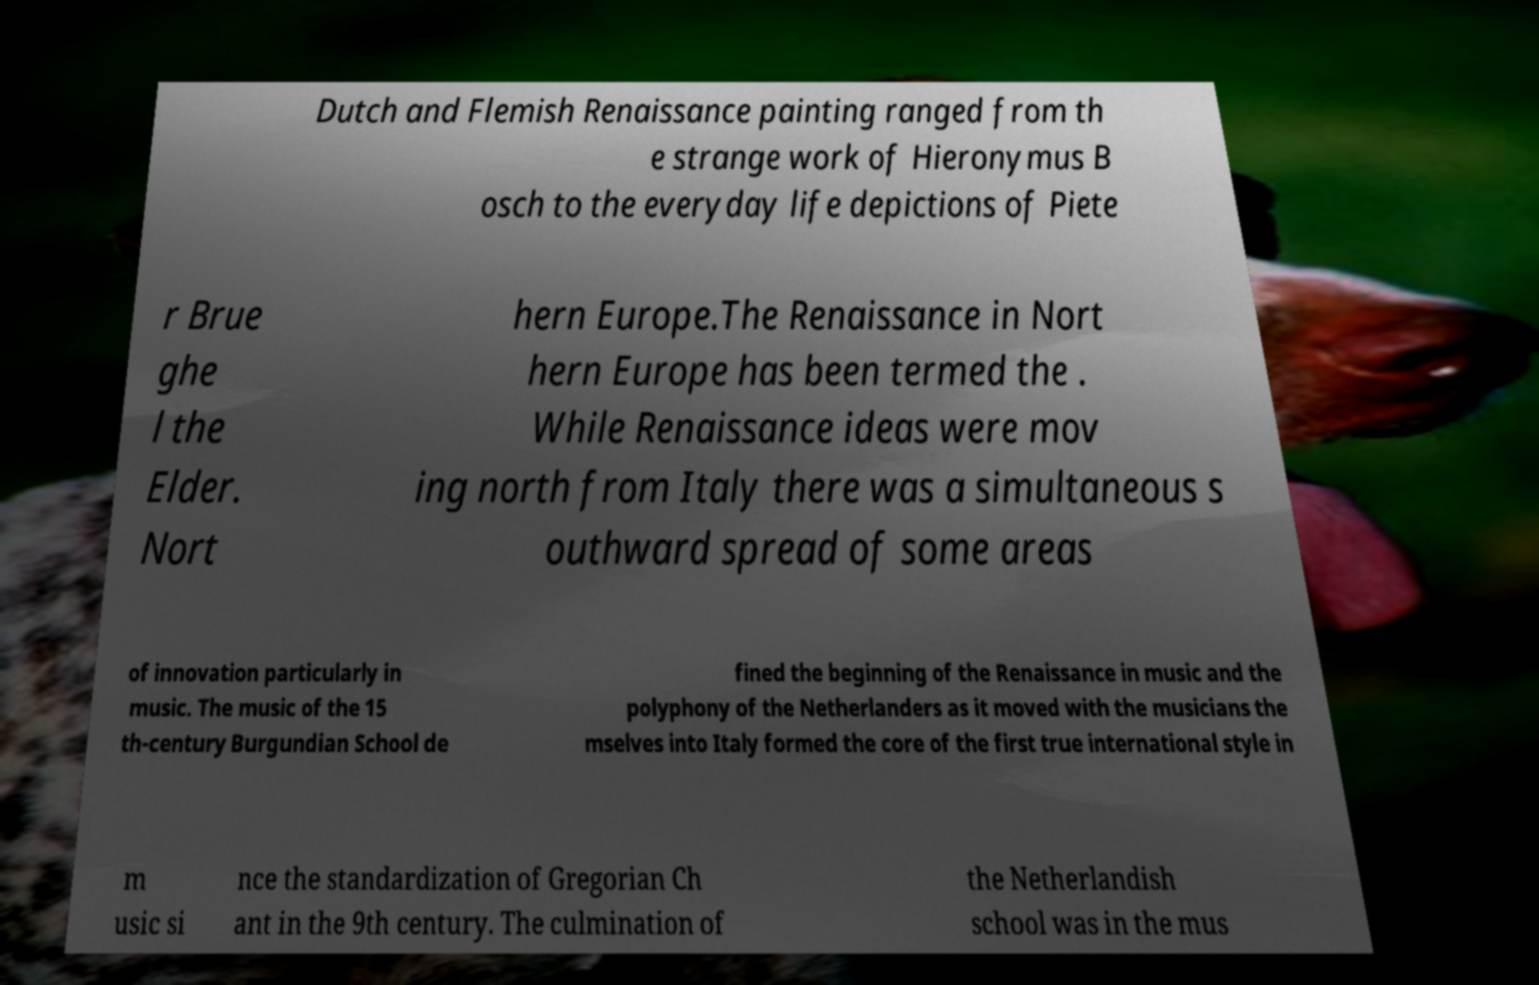Could you assist in decoding the text presented in this image and type it out clearly? Dutch and Flemish Renaissance painting ranged from th e strange work of Hieronymus B osch to the everyday life depictions of Piete r Brue ghe l the Elder. Nort hern Europe.The Renaissance in Nort hern Europe has been termed the . While Renaissance ideas were mov ing north from Italy there was a simultaneous s outhward spread of some areas of innovation particularly in music. The music of the 15 th-century Burgundian School de fined the beginning of the Renaissance in music and the polyphony of the Netherlanders as it moved with the musicians the mselves into Italy formed the core of the first true international style in m usic si nce the standardization of Gregorian Ch ant in the 9th century. The culmination of the Netherlandish school was in the mus 